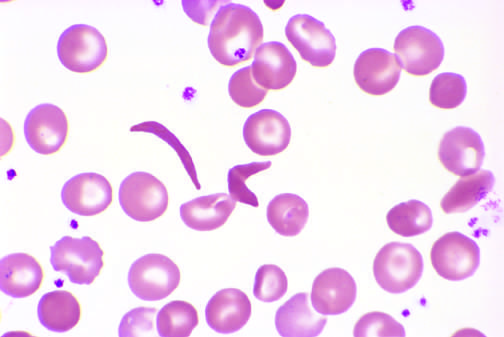does the surrounding lung show an irreversibly sickled cell in the center?
Answer the question using a single word or phrase. No 